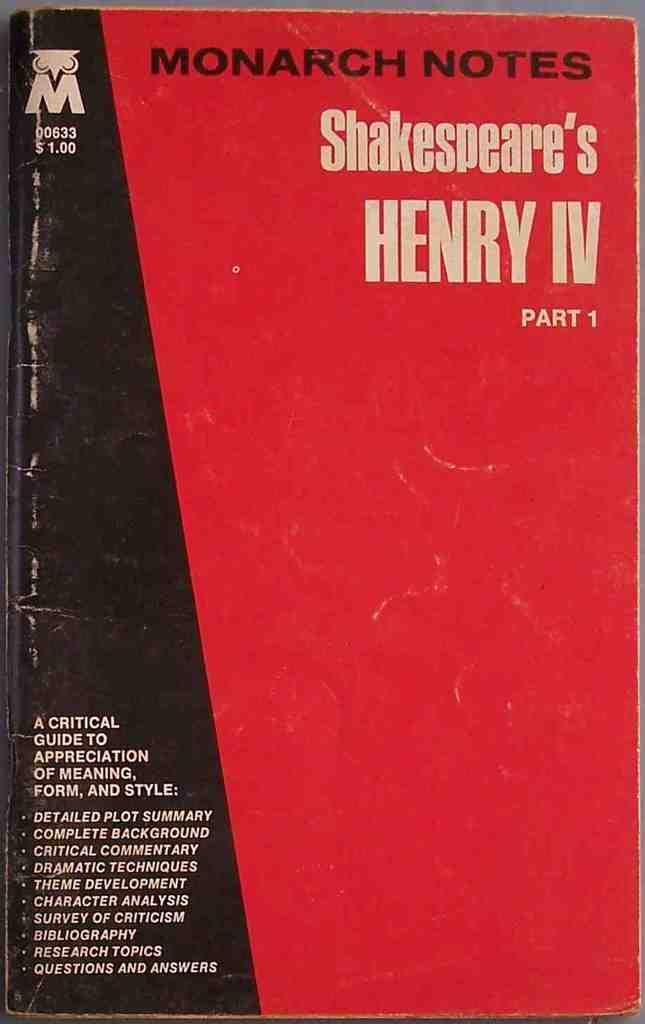Provide a one-sentence caption for the provided image.
Reference OCR token: MONARCH, NOTES, M, 00633, $1.00, Shakespeare's, HENRY, IV, PART, 1, CRITICAL, GUIDET, APPRECIATION, OFMEANING,, FORM,, AND, STYLE:, DETAILEDPL, SUMMARY, MPLETACKGROUND, CRITICAL, COMMENTARY, DRAMATIC, TECHNIQUES, THEME, CHARACTER, SURVEY, RITICISM, BIBLIOGRAPHY, ESEARCHTOPICS, QUESTIONS, ANSWERS A red and black book is titled MONARCH NOTES Shakespeare's HENRY IV. 